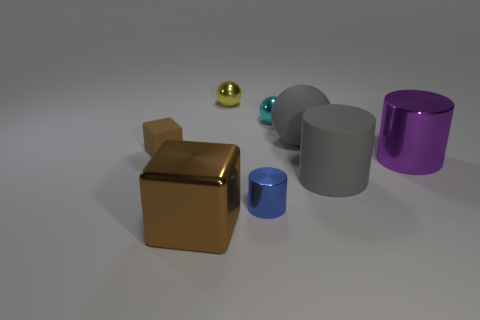Add 1 blue rubber spheres. How many objects exist? 9 Subtract all cubes. How many objects are left? 6 Subtract all tiny blue metallic objects. Subtract all small blue metallic objects. How many objects are left? 6 Add 6 large matte cylinders. How many large matte cylinders are left? 7 Add 4 tiny blue metallic blocks. How many tiny blue metallic blocks exist? 4 Subtract 0 brown balls. How many objects are left? 8 